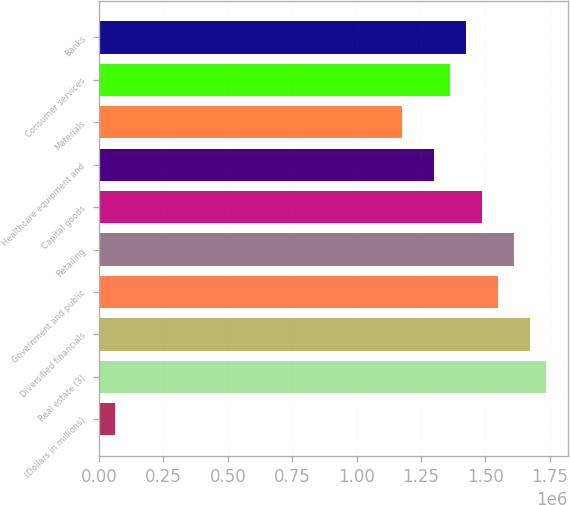Convert chart to OTSL. <chart><loc_0><loc_0><loc_500><loc_500><bar_chart><fcel>(Dollars in millions)<fcel>Real estate (3)<fcel>Diversified financials<fcel>Government and public<fcel>Retailing<fcel>Capital goods<fcel>Healthcare equipment and<fcel>Materials<fcel>Consumer services<fcel>Banks<nl><fcel>63215.3<fcel>1.7332e+06<fcel>1.67135e+06<fcel>1.54765e+06<fcel>1.6095e+06<fcel>1.4858e+06<fcel>1.30024e+06<fcel>1.17654e+06<fcel>1.36209e+06<fcel>1.42394e+06<nl></chart> 